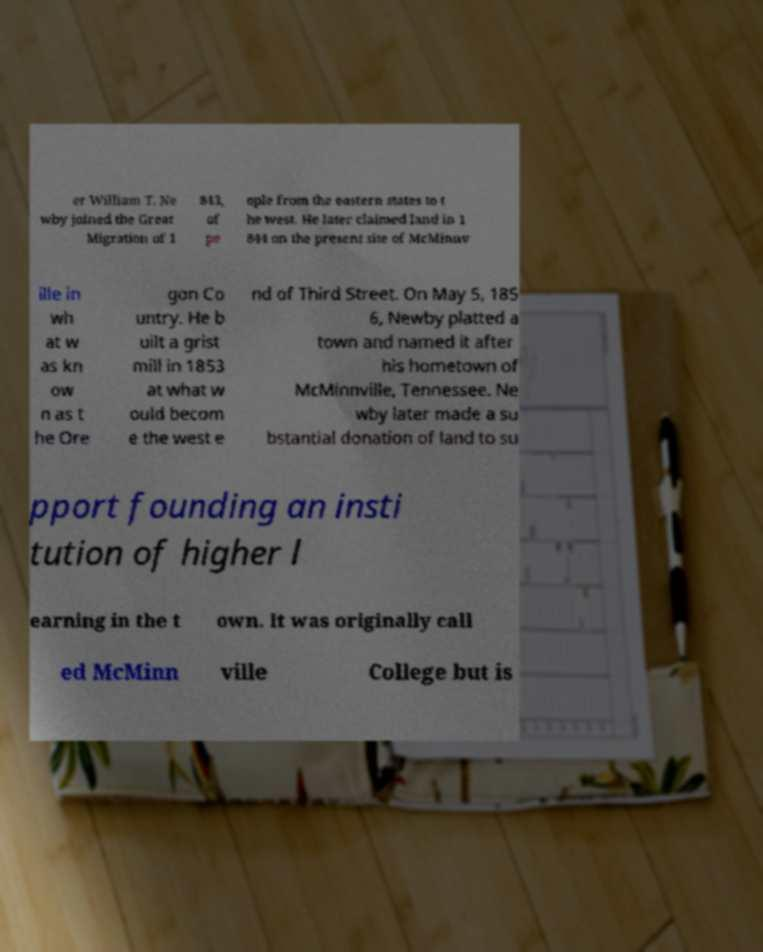There's text embedded in this image that I need extracted. Can you transcribe it verbatim? er William T. Ne wby joined the Great Migration of 1 843, of pe ople from the eastern states to t he west. He later claimed land in 1 844 on the present site of McMinnv ille in wh at w as kn ow n as t he Ore gon Co untry. He b uilt a grist mill in 1853 at what w ould becom e the west e nd of Third Street. On May 5, 185 6, Newby platted a town and named it after his hometown of McMinnville, Tennessee. Ne wby later made a su bstantial donation of land to su pport founding an insti tution of higher l earning in the t own. It was originally call ed McMinn ville College but is 